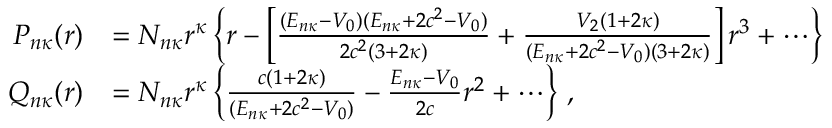<formula> <loc_0><loc_0><loc_500><loc_500>\begin{array} { r } { \begin{array} { r l } { P _ { n \kappa } ( r ) } & { = N _ { n \kappa } r ^ { \kappa } \left \{ r - \left [ \frac { ( E _ { n \kappa } - V _ { 0 } ) ( E _ { n \kappa } + 2 c ^ { 2 } - V _ { 0 } ) } { 2 c ^ { 2 } ( 3 + 2 \kappa ) } + \frac { V _ { 2 } ( 1 + 2 \kappa ) } { ( E _ { n \kappa } + 2 c ^ { 2 } - V _ { 0 } ) ( 3 + 2 \kappa ) } \right ] r ^ { 3 } + \cdots \right \} } \\ { Q _ { n \kappa } ( r ) } & { = N _ { n \kappa } r ^ { \kappa } \left \{ \frac { c ( 1 + 2 \kappa ) } { ( E _ { n \kappa } + 2 c ^ { 2 } - V _ { 0 } ) } - \frac { E _ { n \kappa } - V _ { 0 } } { 2 c } r ^ { 2 } + \cdots \right \} \, , } \end{array} } \end{array}</formula> 